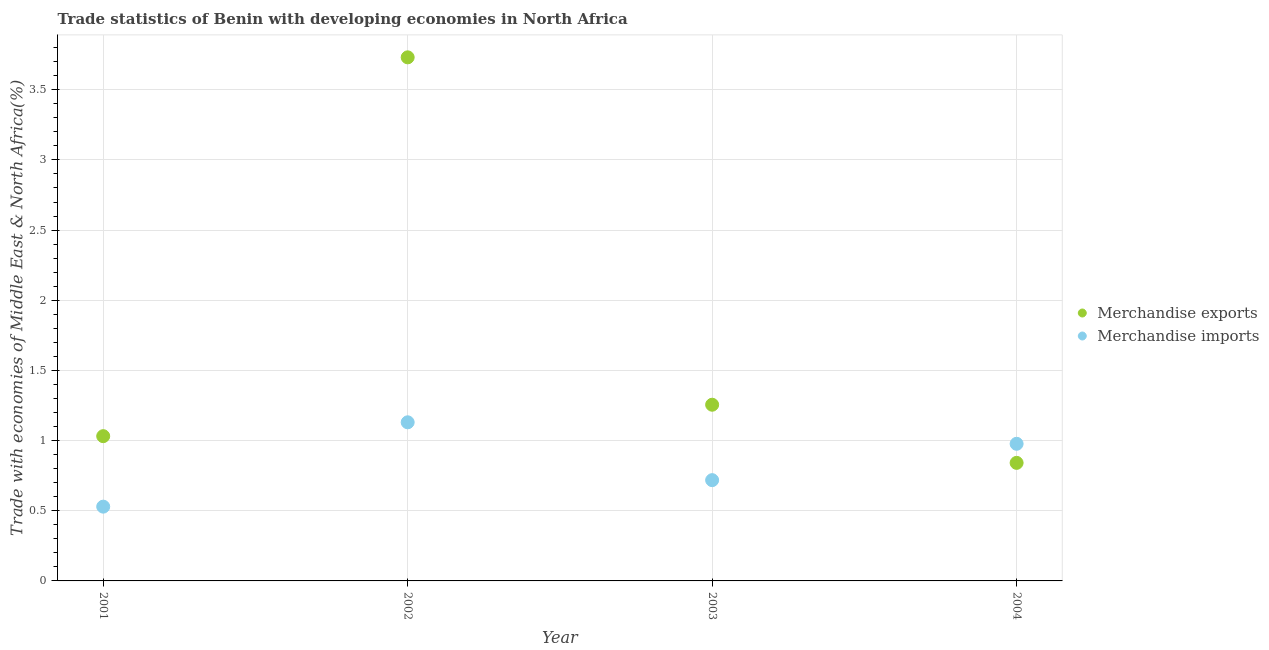What is the merchandise imports in 2003?
Your answer should be very brief. 0.72. Across all years, what is the maximum merchandise imports?
Provide a short and direct response. 1.13. Across all years, what is the minimum merchandise exports?
Your response must be concise. 0.84. In which year was the merchandise imports maximum?
Provide a short and direct response. 2002. What is the total merchandise exports in the graph?
Your answer should be very brief. 6.86. What is the difference between the merchandise imports in 2001 and that in 2003?
Ensure brevity in your answer.  -0.19. What is the difference between the merchandise imports in 2003 and the merchandise exports in 2001?
Make the answer very short. -0.31. What is the average merchandise imports per year?
Provide a short and direct response. 0.84. In the year 2001, what is the difference between the merchandise imports and merchandise exports?
Make the answer very short. -0.5. In how many years, is the merchandise imports greater than 1.4 %?
Your answer should be very brief. 0. What is the ratio of the merchandise exports in 2003 to that in 2004?
Ensure brevity in your answer.  1.49. Is the difference between the merchandise imports in 2001 and 2002 greater than the difference between the merchandise exports in 2001 and 2002?
Offer a terse response. Yes. What is the difference between the highest and the second highest merchandise exports?
Your answer should be compact. 2.48. What is the difference between the highest and the lowest merchandise exports?
Your answer should be compact. 2.89. In how many years, is the merchandise imports greater than the average merchandise imports taken over all years?
Ensure brevity in your answer.  2. Does the merchandise imports monotonically increase over the years?
Keep it short and to the point. No. Is the merchandise exports strictly less than the merchandise imports over the years?
Give a very brief answer. No. How many dotlines are there?
Offer a very short reply. 2. What is the difference between two consecutive major ticks on the Y-axis?
Your answer should be very brief. 0.5. How many legend labels are there?
Provide a short and direct response. 2. What is the title of the graph?
Make the answer very short. Trade statistics of Benin with developing economies in North Africa. What is the label or title of the Y-axis?
Give a very brief answer. Trade with economies of Middle East & North Africa(%). What is the Trade with economies of Middle East & North Africa(%) of Merchandise exports in 2001?
Keep it short and to the point. 1.03. What is the Trade with economies of Middle East & North Africa(%) in Merchandise imports in 2001?
Provide a short and direct response. 0.53. What is the Trade with economies of Middle East & North Africa(%) of Merchandise exports in 2002?
Offer a terse response. 3.73. What is the Trade with economies of Middle East & North Africa(%) in Merchandise imports in 2002?
Keep it short and to the point. 1.13. What is the Trade with economies of Middle East & North Africa(%) of Merchandise exports in 2003?
Offer a terse response. 1.26. What is the Trade with economies of Middle East & North Africa(%) of Merchandise imports in 2003?
Give a very brief answer. 0.72. What is the Trade with economies of Middle East & North Africa(%) of Merchandise exports in 2004?
Ensure brevity in your answer.  0.84. What is the Trade with economies of Middle East & North Africa(%) of Merchandise imports in 2004?
Give a very brief answer. 0.98. Across all years, what is the maximum Trade with economies of Middle East & North Africa(%) in Merchandise exports?
Provide a short and direct response. 3.73. Across all years, what is the maximum Trade with economies of Middle East & North Africa(%) of Merchandise imports?
Provide a short and direct response. 1.13. Across all years, what is the minimum Trade with economies of Middle East & North Africa(%) in Merchandise exports?
Your answer should be compact. 0.84. Across all years, what is the minimum Trade with economies of Middle East & North Africa(%) in Merchandise imports?
Offer a very short reply. 0.53. What is the total Trade with economies of Middle East & North Africa(%) of Merchandise exports in the graph?
Give a very brief answer. 6.86. What is the total Trade with economies of Middle East & North Africa(%) of Merchandise imports in the graph?
Your response must be concise. 3.35. What is the difference between the Trade with economies of Middle East & North Africa(%) in Merchandise exports in 2001 and that in 2002?
Provide a succinct answer. -2.7. What is the difference between the Trade with economies of Middle East & North Africa(%) of Merchandise imports in 2001 and that in 2002?
Your answer should be very brief. -0.6. What is the difference between the Trade with economies of Middle East & North Africa(%) of Merchandise exports in 2001 and that in 2003?
Make the answer very short. -0.22. What is the difference between the Trade with economies of Middle East & North Africa(%) in Merchandise imports in 2001 and that in 2003?
Ensure brevity in your answer.  -0.19. What is the difference between the Trade with economies of Middle East & North Africa(%) of Merchandise exports in 2001 and that in 2004?
Your response must be concise. 0.19. What is the difference between the Trade with economies of Middle East & North Africa(%) of Merchandise imports in 2001 and that in 2004?
Your answer should be compact. -0.45. What is the difference between the Trade with economies of Middle East & North Africa(%) in Merchandise exports in 2002 and that in 2003?
Ensure brevity in your answer.  2.48. What is the difference between the Trade with economies of Middle East & North Africa(%) in Merchandise imports in 2002 and that in 2003?
Your response must be concise. 0.41. What is the difference between the Trade with economies of Middle East & North Africa(%) of Merchandise exports in 2002 and that in 2004?
Ensure brevity in your answer.  2.89. What is the difference between the Trade with economies of Middle East & North Africa(%) of Merchandise imports in 2002 and that in 2004?
Provide a succinct answer. 0.15. What is the difference between the Trade with economies of Middle East & North Africa(%) of Merchandise exports in 2003 and that in 2004?
Provide a short and direct response. 0.41. What is the difference between the Trade with economies of Middle East & North Africa(%) in Merchandise imports in 2003 and that in 2004?
Make the answer very short. -0.26. What is the difference between the Trade with economies of Middle East & North Africa(%) of Merchandise exports in 2001 and the Trade with economies of Middle East & North Africa(%) of Merchandise imports in 2002?
Ensure brevity in your answer.  -0.1. What is the difference between the Trade with economies of Middle East & North Africa(%) in Merchandise exports in 2001 and the Trade with economies of Middle East & North Africa(%) in Merchandise imports in 2003?
Make the answer very short. 0.31. What is the difference between the Trade with economies of Middle East & North Africa(%) in Merchandise exports in 2001 and the Trade with economies of Middle East & North Africa(%) in Merchandise imports in 2004?
Keep it short and to the point. 0.05. What is the difference between the Trade with economies of Middle East & North Africa(%) of Merchandise exports in 2002 and the Trade with economies of Middle East & North Africa(%) of Merchandise imports in 2003?
Your answer should be compact. 3.01. What is the difference between the Trade with economies of Middle East & North Africa(%) of Merchandise exports in 2002 and the Trade with economies of Middle East & North Africa(%) of Merchandise imports in 2004?
Offer a terse response. 2.75. What is the difference between the Trade with economies of Middle East & North Africa(%) of Merchandise exports in 2003 and the Trade with economies of Middle East & North Africa(%) of Merchandise imports in 2004?
Give a very brief answer. 0.28. What is the average Trade with economies of Middle East & North Africa(%) of Merchandise exports per year?
Give a very brief answer. 1.71. What is the average Trade with economies of Middle East & North Africa(%) of Merchandise imports per year?
Offer a terse response. 0.84. In the year 2001, what is the difference between the Trade with economies of Middle East & North Africa(%) in Merchandise exports and Trade with economies of Middle East & North Africa(%) in Merchandise imports?
Ensure brevity in your answer.  0.5. In the year 2002, what is the difference between the Trade with economies of Middle East & North Africa(%) of Merchandise exports and Trade with economies of Middle East & North Africa(%) of Merchandise imports?
Make the answer very short. 2.6. In the year 2003, what is the difference between the Trade with economies of Middle East & North Africa(%) in Merchandise exports and Trade with economies of Middle East & North Africa(%) in Merchandise imports?
Keep it short and to the point. 0.54. In the year 2004, what is the difference between the Trade with economies of Middle East & North Africa(%) of Merchandise exports and Trade with economies of Middle East & North Africa(%) of Merchandise imports?
Your response must be concise. -0.14. What is the ratio of the Trade with economies of Middle East & North Africa(%) of Merchandise exports in 2001 to that in 2002?
Provide a short and direct response. 0.28. What is the ratio of the Trade with economies of Middle East & North Africa(%) of Merchandise imports in 2001 to that in 2002?
Offer a very short reply. 0.47. What is the ratio of the Trade with economies of Middle East & North Africa(%) in Merchandise exports in 2001 to that in 2003?
Ensure brevity in your answer.  0.82. What is the ratio of the Trade with economies of Middle East & North Africa(%) in Merchandise imports in 2001 to that in 2003?
Make the answer very short. 0.74. What is the ratio of the Trade with economies of Middle East & North Africa(%) in Merchandise exports in 2001 to that in 2004?
Your answer should be very brief. 1.23. What is the ratio of the Trade with economies of Middle East & North Africa(%) of Merchandise imports in 2001 to that in 2004?
Offer a terse response. 0.54. What is the ratio of the Trade with economies of Middle East & North Africa(%) of Merchandise exports in 2002 to that in 2003?
Give a very brief answer. 2.97. What is the ratio of the Trade with economies of Middle East & North Africa(%) in Merchandise imports in 2002 to that in 2003?
Ensure brevity in your answer.  1.57. What is the ratio of the Trade with economies of Middle East & North Africa(%) of Merchandise exports in 2002 to that in 2004?
Make the answer very short. 4.43. What is the ratio of the Trade with economies of Middle East & North Africa(%) of Merchandise imports in 2002 to that in 2004?
Offer a very short reply. 1.16. What is the ratio of the Trade with economies of Middle East & North Africa(%) of Merchandise exports in 2003 to that in 2004?
Ensure brevity in your answer.  1.49. What is the ratio of the Trade with economies of Middle East & North Africa(%) in Merchandise imports in 2003 to that in 2004?
Make the answer very short. 0.73. What is the difference between the highest and the second highest Trade with economies of Middle East & North Africa(%) in Merchandise exports?
Your answer should be very brief. 2.48. What is the difference between the highest and the second highest Trade with economies of Middle East & North Africa(%) in Merchandise imports?
Your answer should be compact. 0.15. What is the difference between the highest and the lowest Trade with economies of Middle East & North Africa(%) in Merchandise exports?
Provide a succinct answer. 2.89. What is the difference between the highest and the lowest Trade with economies of Middle East & North Africa(%) in Merchandise imports?
Give a very brief answer. 0.6. 